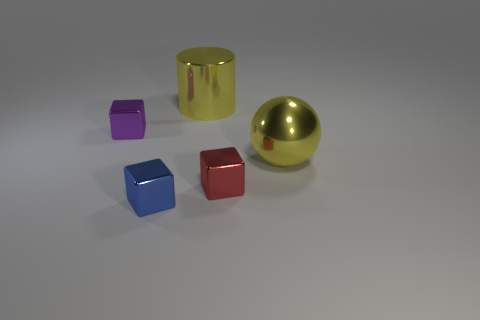Add 2 cylinders. How many objects exist? 7 Subtract all blocks. How many objects are left? 2 Add 3 small purple metallic objects. How many small purple metallic objects are left? 4 Add 5 big shiny balls. How many big shiny balls exist? 6 Subtract 0 red balls. How many objects are left? 5 Subtract all green spheres. Subtract all yellow metal things. How many objects are left? 3 